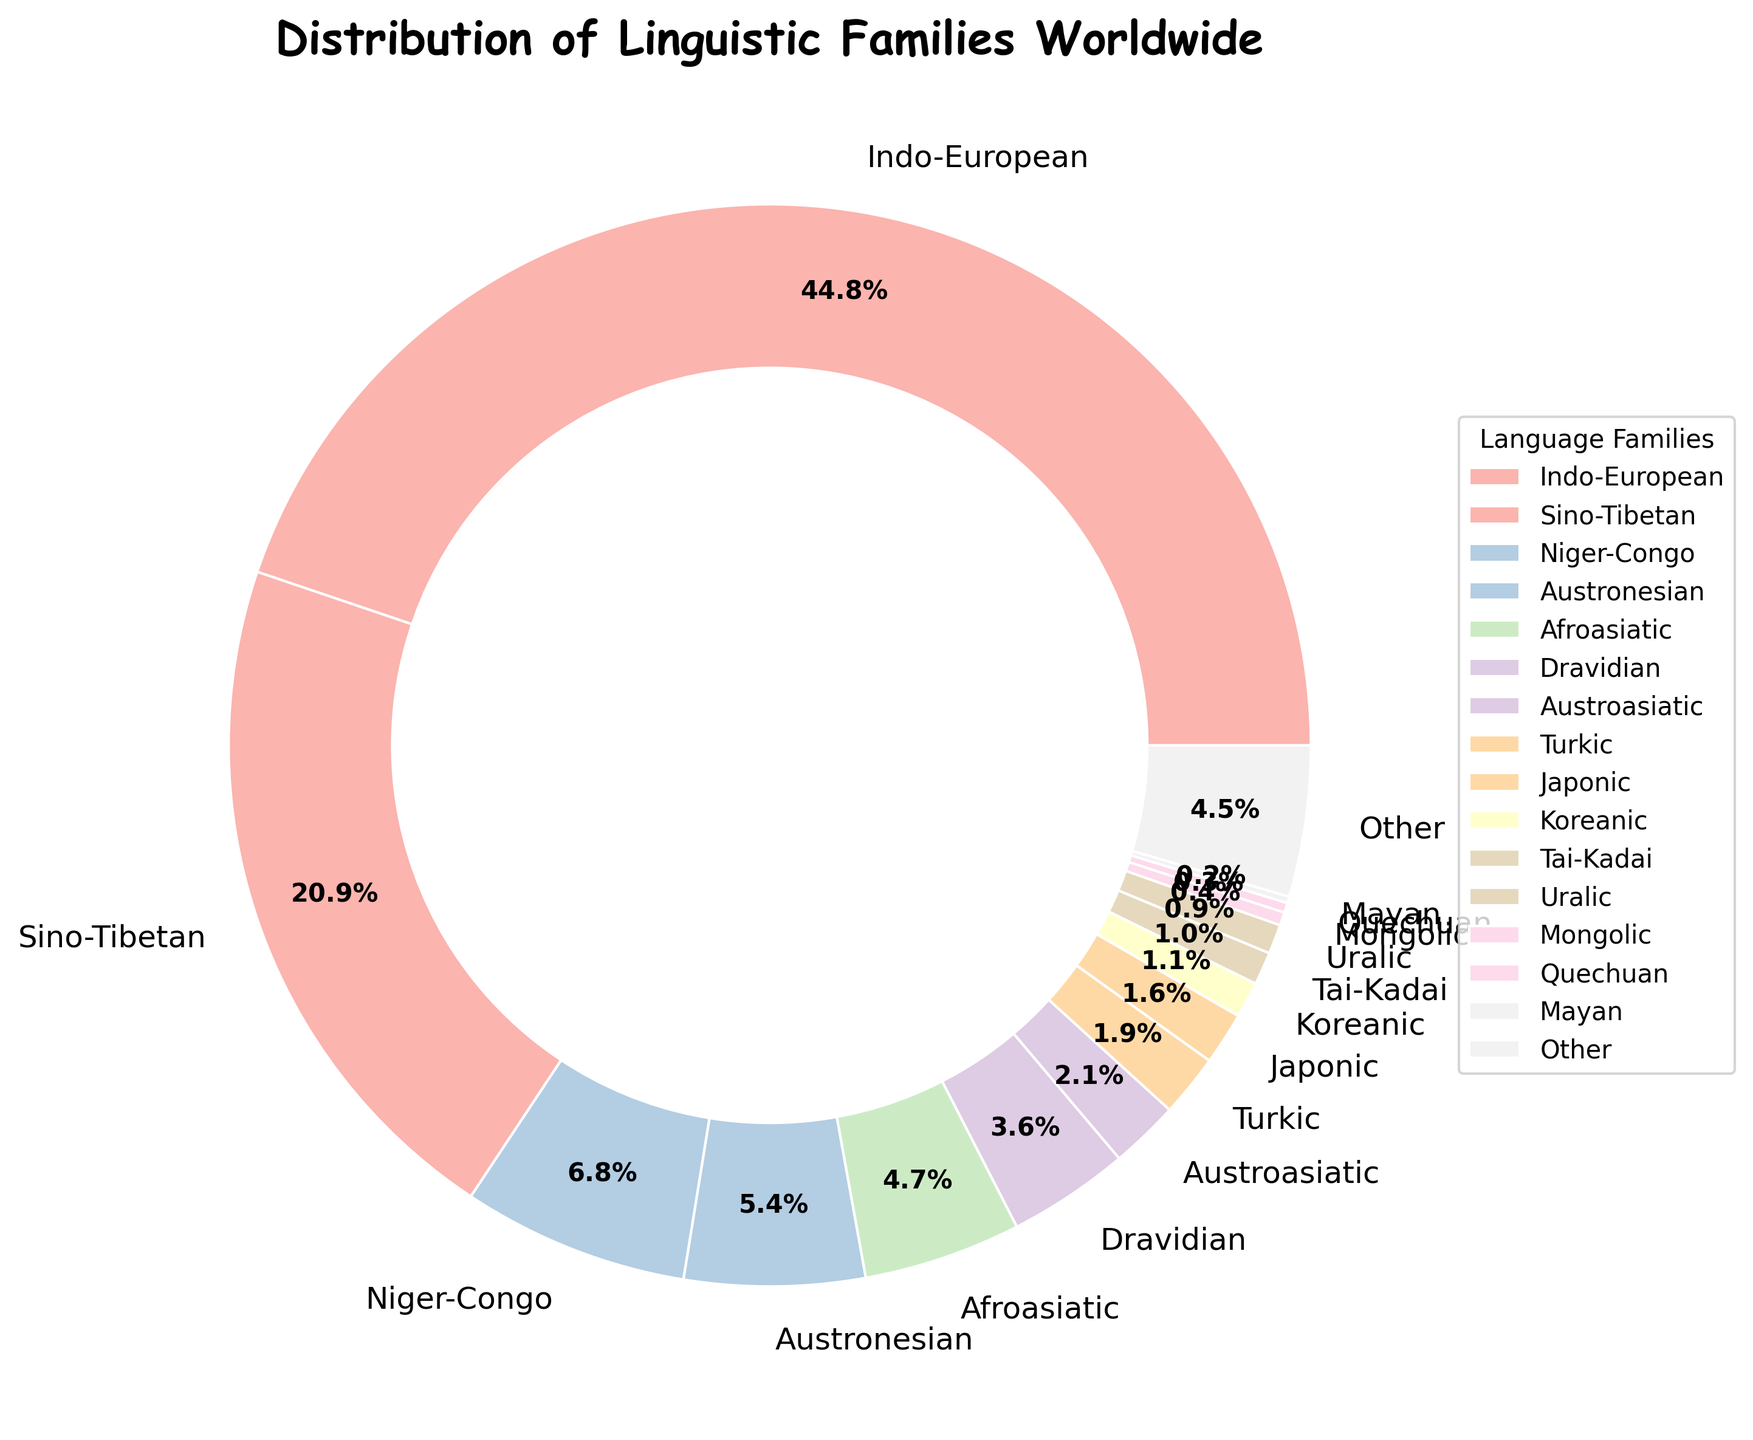What's the most dominant language family shown in the pie chart? The Indo-European language family takes up the largest portion of the pie chart, indicating it is the most dominant.
Answer: Indo-European What percentage of the world's languages belong to the Sino-Tibetan family? According to the pie chart, the Sino-Tibetan family is labeled with a percentage showing its portion of the distribution.
Answer: 21.3% How many language families comprise less than 2% of the distribution? The families with percentages less than 2% are Turkic (1.9%), Japonic (1.6%), Koreanic (1.1%), Tai-Kadai (1.0%), Uralic (0.9%), Mongolic (0.4%), Quechuan (0.3%), and Mayan (0.2%). Counting these shows that there are 8 families.
Answer: 8 What is the combined percentage of Afroasiatic and Dravidian language families? The pie chart shows Afroasiatic at 4.8% and Dravidian at 3.7%. Adding these together gives 4.8% + 3.7% = 8.5%.
Answer: 8.5% Which language family has a slightly larger share than the Austroasiatic family? The pie chart indicates that Turkic has 1.9% which is slightly higher than Austroasiatic's 2.1%.
Answer: Turkic What is the rank of the Austronesian family in terms of percentage distribution? The pie chart displays percentages, and Austronesian with 5.5% falls after Indo-European (45.7%) and Sino-Tibetan (21.3%), which means it's the third largest.
Answer: 3rd Which section of the pie chart is visually the smallest? By observing the sizes, the smallest section corresponds to the Mayan language family, occupying only 0.2%.
Answer: Mayan How does the Japonic family compare to the Koreanic family in the pie chart? The pie chart shows Japonic at 1.6% and Koreanic at 1.1%, which means Japonic has a larger share.
Answer: Japonic has a larger share If you combine the percentages of the Australasian and Uralic families, do they exceed the Turkic family? The pie chart lists Austroasiatic at 2.1% and Uralic at 0.9%. Their combined total is 2.1% + 0.9% = 3.0%, which does exceed the Turkic family at 1.9%.
Answer: Yes, they do exceed the Turkic family 